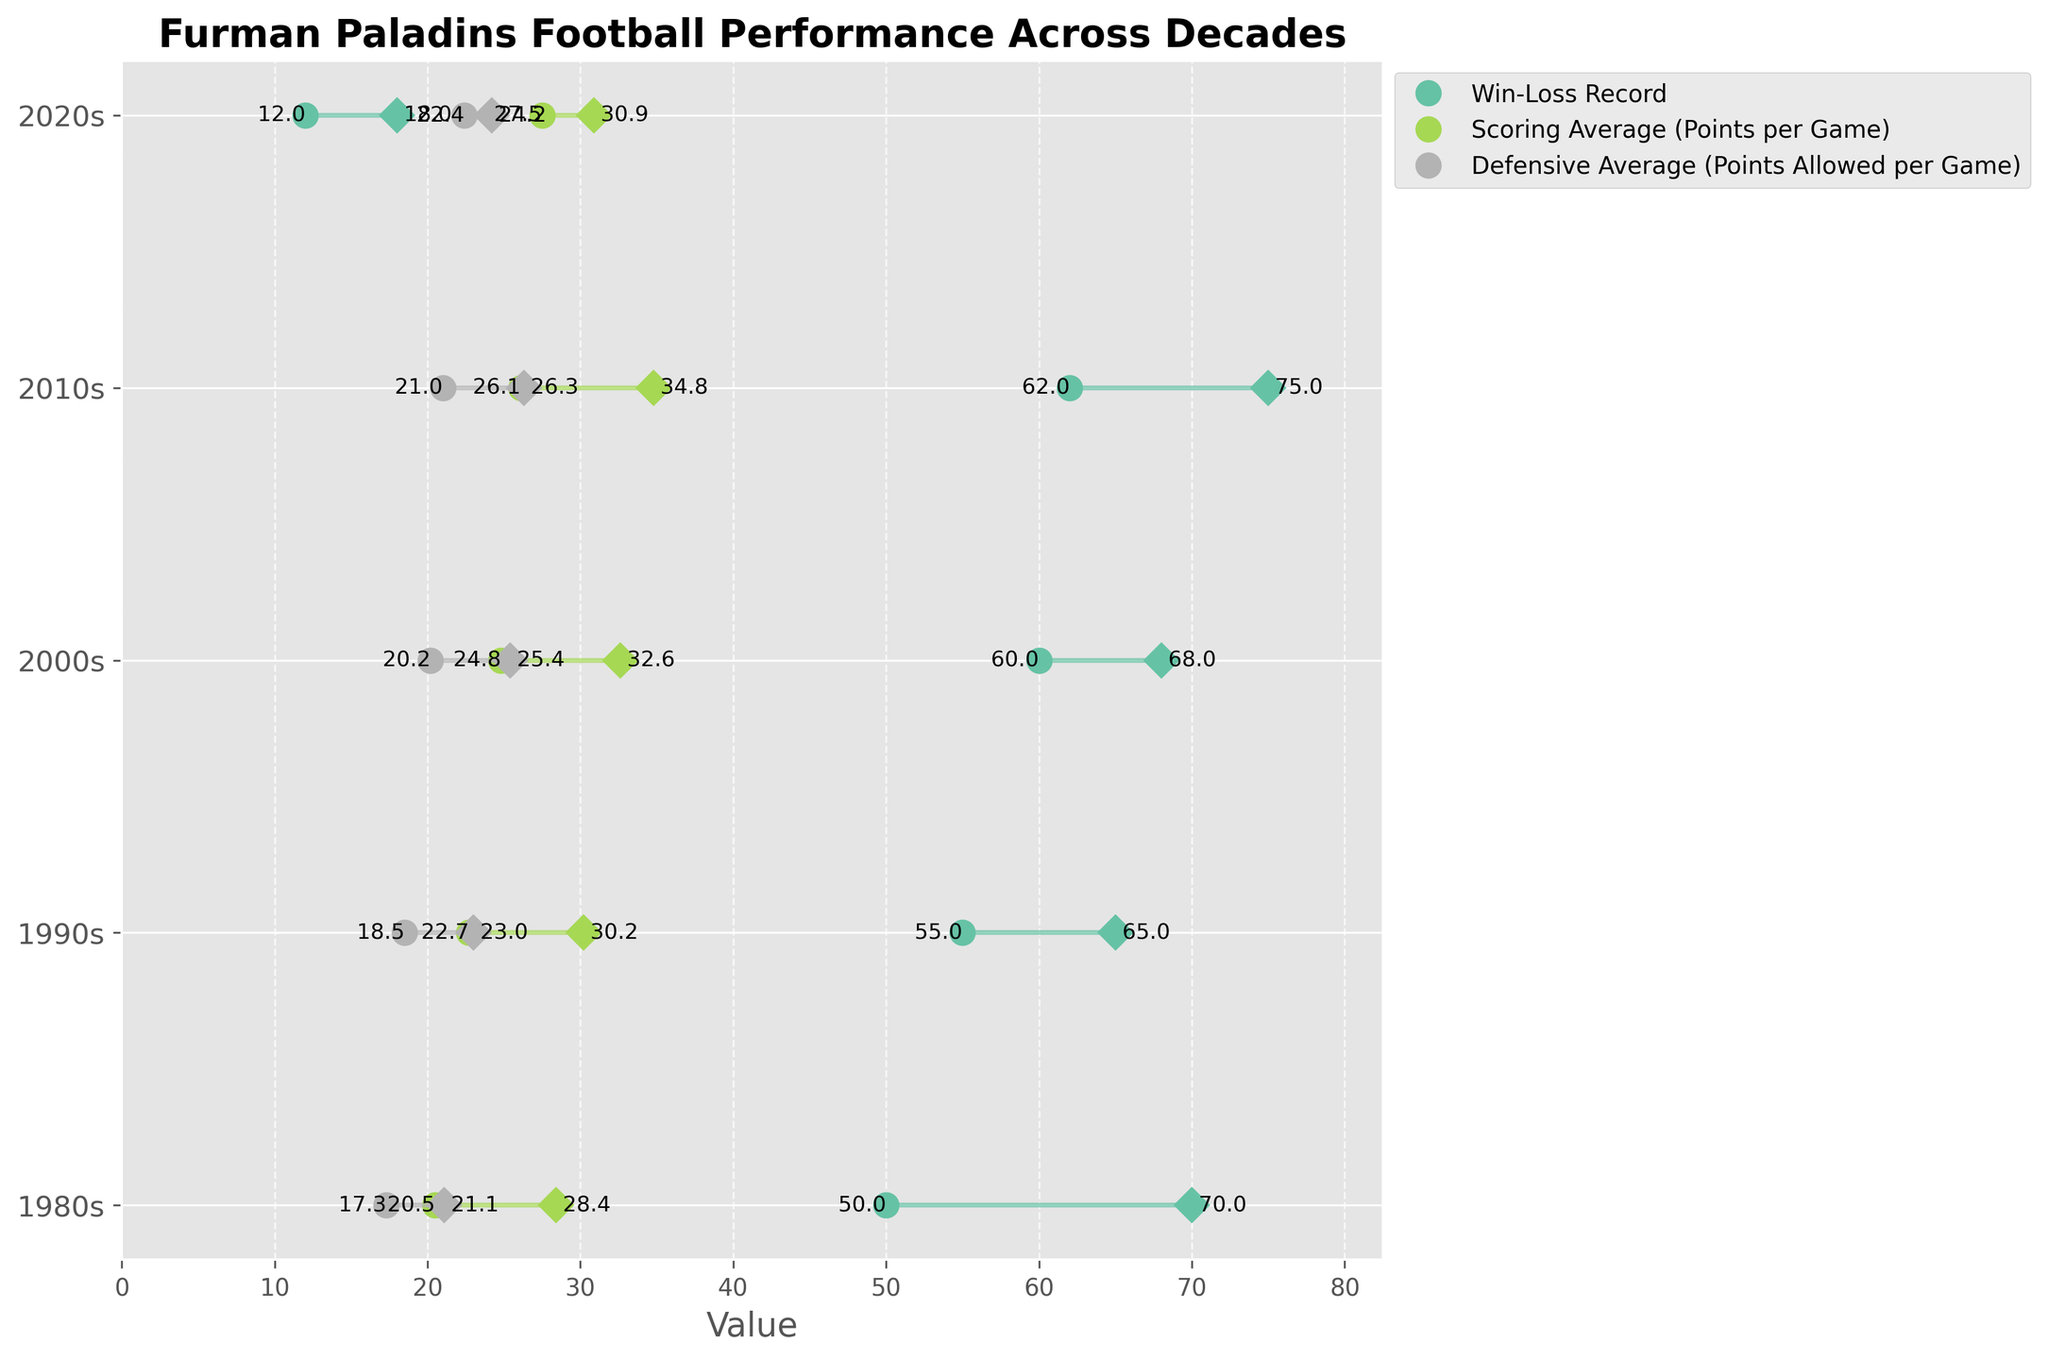What is the title of the plot? The title of the plot is typically placed at the top and is clearly labeled as such. In this case, it reads "Furman Paladins Football Performance Across Decades".
Answer: Furman Paladins Football Performance Across Decades What is the trend in the Win-Loss Record from the 1980s to the 2010s? To find the trend, we look at the end values of the Win-Loss Record for each decade. The values are 70 for the 1980s, 65 for the 1990s, 68 for the 2000s, and 75 for the 2010s. Notice that after a slight dip in the 1990s, the Win-Loss Record increased in the 2000s and 2010s.
Answer: Increasing with a dip in the 1990s What was the increase in Scoring Average (Points per Game) from the start of the 1980s to the end of the 2020s? We need to subtract the start value of the 1980s (20.5) from the end value of the 2020s (30.9). The calculation is 30.9 - 20.5.
Answer: 10.4 How did the Defensive Average (Points Allowed per Game) change from the 1990s to 2000s? The end value for the 1990s is 23.0, and for the 2000s, it is 25.4. By comparing these values, we can see that it increased.
Answer: Increased Which decade had the highest increase in Scoring Average (Points per Game)? To determine this, we need to calculate the difference between the end value and start value for each decade and compare them. The differences are 7.9 (1980s), 7.5 (1990s), 7.8 (2000s), 8.7 (2010s), 3.4 (2020s). The highest increase is in the 2010s.
Answer: 2010s What was the Defensive Average (Points Allowed per Game) for the 2020s at the end of the decade? This can be found in the plot where the defensive stats for the 2020s decade are indicated. The end value is 24.2.
Answer: 24.2 Compare the Win-Loss Record start values of the 1980s and the 2020s. Which decade had a higher start value? To compare, we look at the start values for both decades. The 1980s start value is 50, and the 2020s start value is 12. Hence, the 1980s had a higher start value.
Answer: 1980s What was the difference between the start and end Defensive Average (Points Allowed per Game) in the 2000s? To find the difference, we subtract the start value of the 2000s (20.2) from the end value (25.4). The calculation is 25.4 - 20.2.
Answer: 5.2 